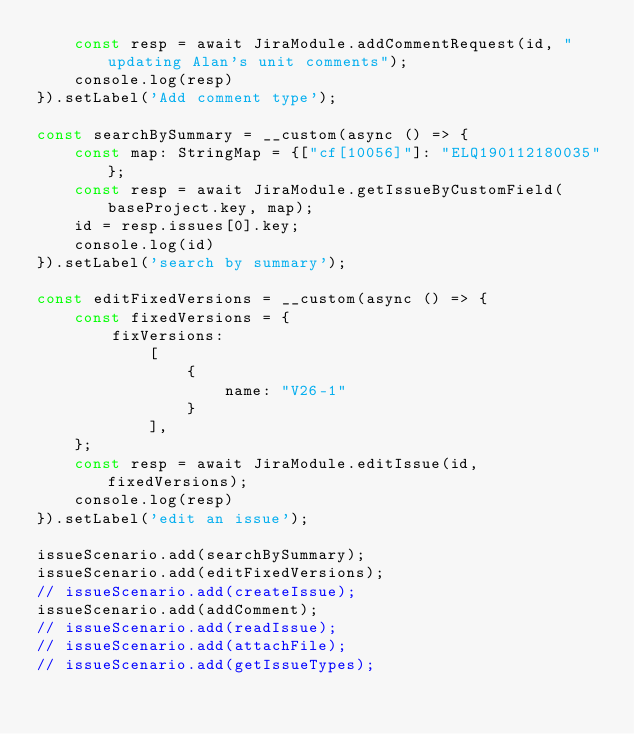Convert code to text. <code><loc_0><loc_0><loc_500><loc_500><_TypeScript_>	const resp = await JiraModule.addCommentRequest(id, "updating Alan's unit comments");
	console.log(resp)
}).setLabel('Add comment type');

const searchBySummary = __custom(async () => {
	const map: StringMap = {["cf[10056]"]: "ELQ190112180035"};
	const resp = await JiraModule.getIssueByCustomField(baseProject.key, map);
	id = resp.issues[0].key;
	console.log(id)
}).setLabel('search by summary');

const editFixedVersions = __custom(async () => {
	const fixedVersions = {
		fixVersions:
			[
				{
					name: "V26-1"
				}
			],
	};
	const resp = await JiraModule.editIssue(id, fixedVersions);
	console.log(resp)
}).setLabel('edit an issue');

issueScenario.add(searchBySummary);
issueScenario.add(editFixedVersions);
// issueScenario.add(createIssue);
issueScenario.add(addComment);
// issueScenario.add(readIssue);
// issueScenario.add(attachFile);
// issueScenario.add(getIssueTypes);

</code> 